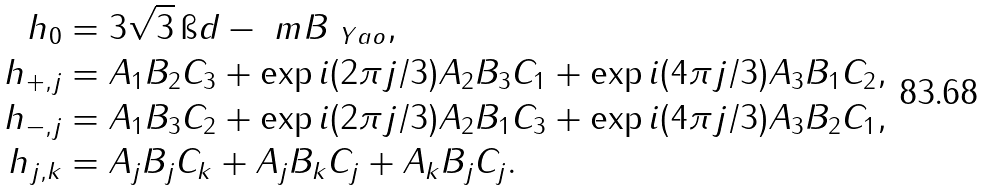Convert formula to latex. <formula><loc_0><loc_0><loc_500><loc_500>h _ { 0 } & = 3 \sqrt { 3 } \, \i d - \ m B _ { \ Y a o } , \\ h _ { + , j } & = A _ { 1 } B _ { 2 } C _ { 3 } + \exp { i ( 2 \pi j / 3 ) } A _ { 2 } B _ { 3 } C _ { 1 } + \exp { i ( 4 \pi j / 3 ) } A _ { 3 } B _ { 1 } C _ { 2 } , \\ h _ { - , j } & = A _ { 1 } B _ { 3 } C _ { 2 } + \exp { i ( 2 \pi j / 3 ) } A _ { 2 } B _ { 1 } C _ { 3 } + \exp { i ( 4 \pi j / 3 ) } A _ { 3 } B _ { 2 } C _ { 1 } , \\ h _ { j , k } & = A _ { j } B _ { j } C _ { k } + A _ { j } B _ { k } C _ { j } + A _ { k } B _ { j } C _ { j } .</formula> 